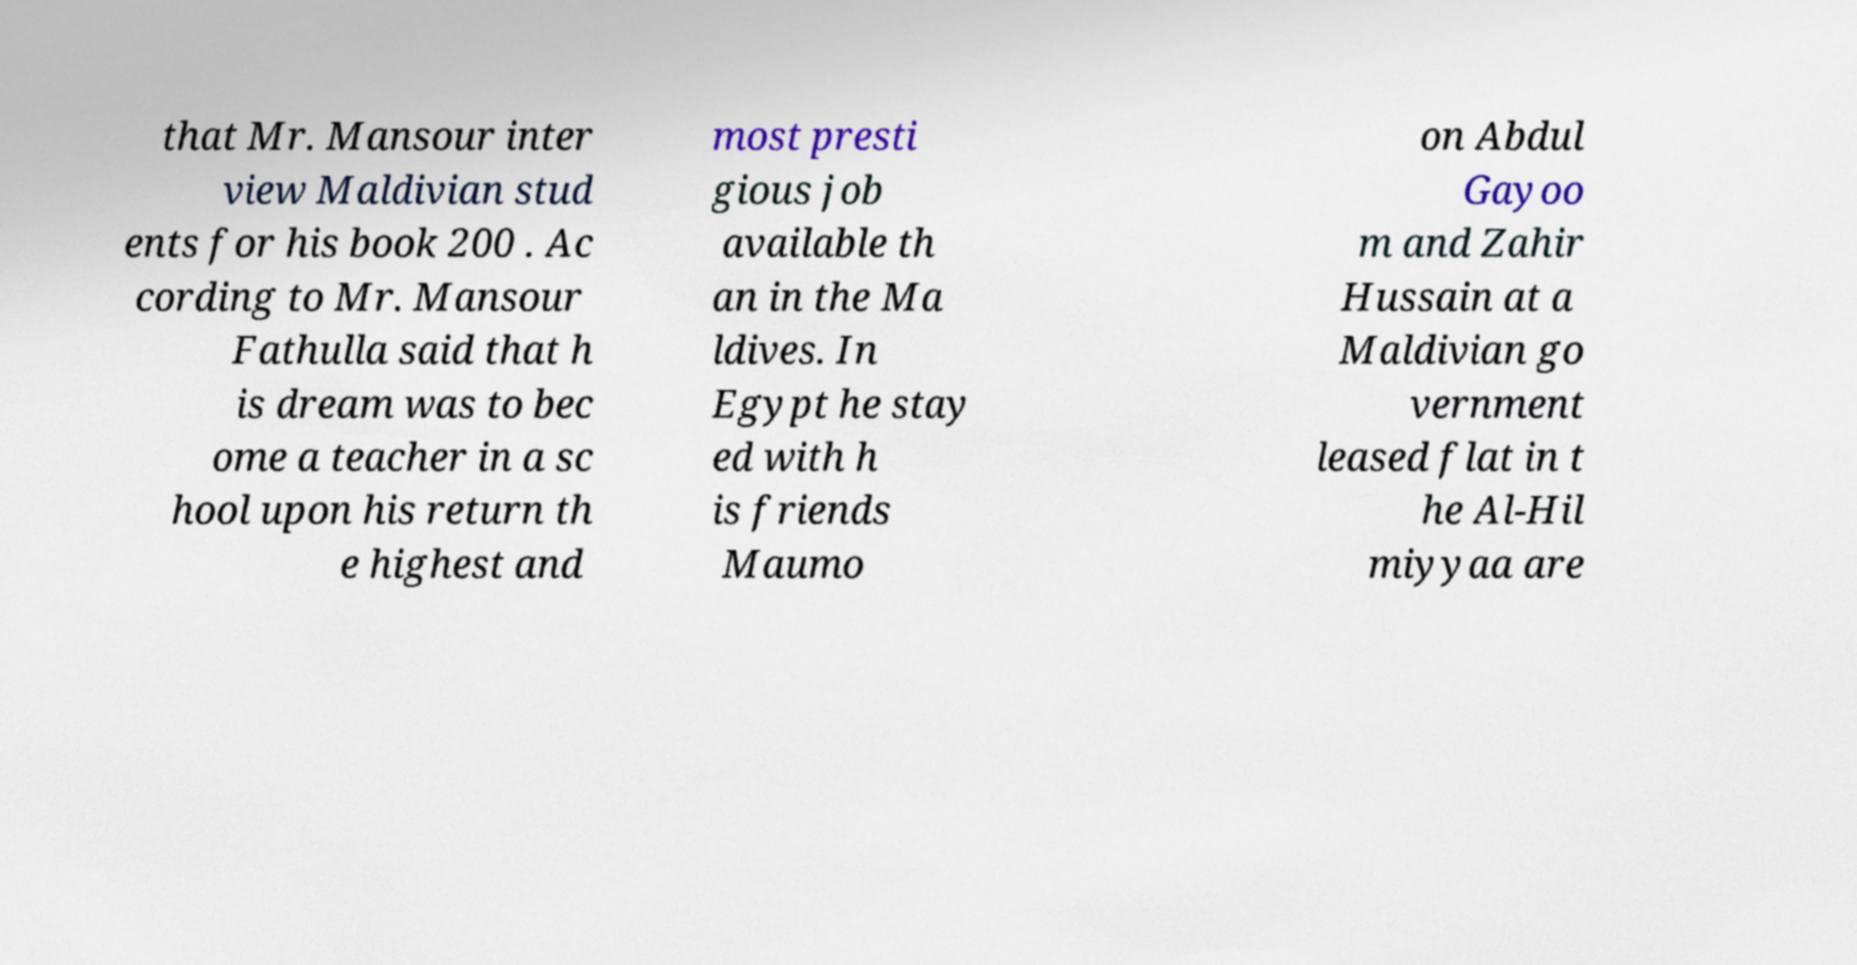Please read and relay the text visible in this image. What does it say? that Mr. Mansour inter view Maldivian stud ents for his book 200 . Ac cording to Mr. Mansour Fathulla said that h is dream was to bec ome a teacher in a sc hool upon his return th e highest and most presti gious job available th an in the Ma ldives. In Egypt he stay ed with h is friends Maumo on Abdul Gayoo m and Zahir Hussain at a Maldivian go vernment leased flat in t he Al-Hil miyyaa are 